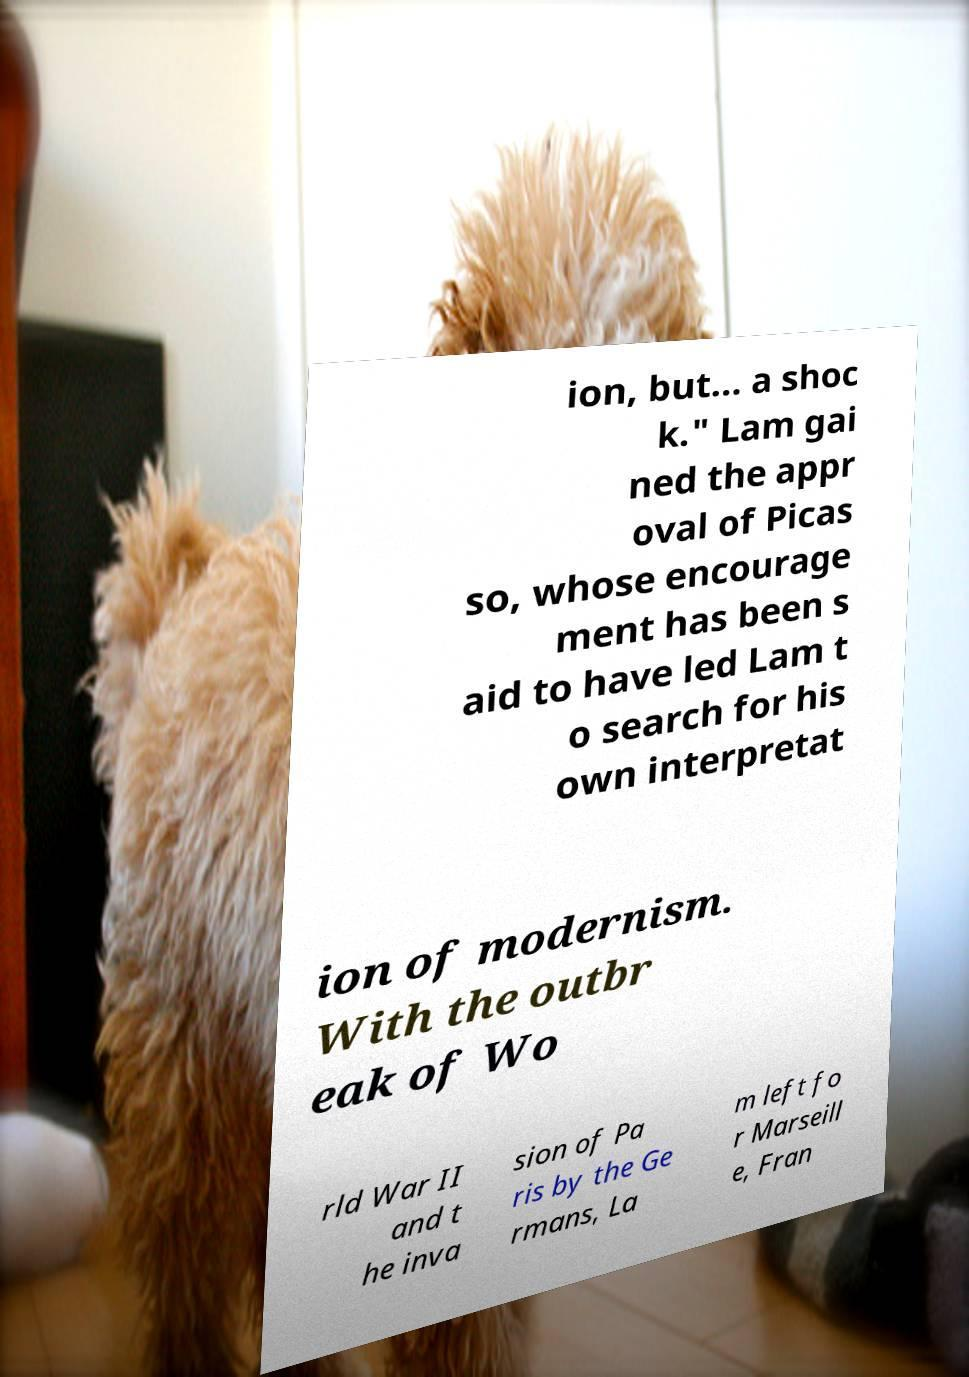Please identify and transcribe the text found in this image. ion, but… a shoc k." Lam gai ned the appr oval of Picas so, whose encourage ment has been s aid to have led Lam t o search for his own interpretat ion of modernism. With the outbr eak of Wo rld War II and t he inva sion of Pa ris by the Ge rmans, La m left fo r Marseill e, Fran 